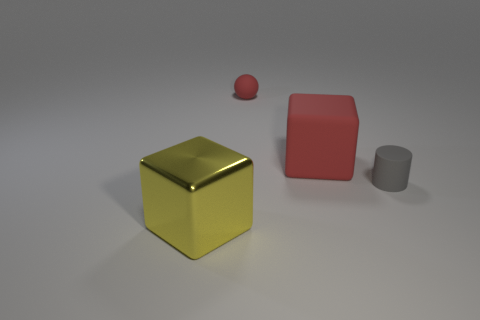Does the yellow metallic thing in front of the gray rubber thing have the same shape as the large thing that is on the right side of the yellow cube?
Provide a short and direct response. Yes. How many objects are either tiny red matte objects or tiny things on the left side of the tiny matte cylinder?
Offer a very short reply. 1. The tiny rubber object that is the same color as the big rubber thing is what shape?
Keep it short and to the point. Sphere. What number of other objects are the same size as the yellow shiny thing?
Offer a very short reply. 1. What number of red objects are either large metallic cubes or large objects?
Provide a succinct answer. 1. What shape is the big thing that is in front of the gray object that is on the right side of the large yellow metallic object?
Your answer should be very brief. Cube. What shape is the red rubber thing that is the same size as the gray cylinder?
Give a very brief answer. Sphere. Is there a large shiny block that has the same color as the cylinder?
Offer a very short reply. No. Is the number of big red matte things that are in front of the metal object the same as the number of small cylinders behind the tiny red thing?
Provide a short and direct response. Yes. There is a yellow thing; does it have the same shape as the gray rubber object in front of the large red rubber cube?
Your response must be concise. No. 